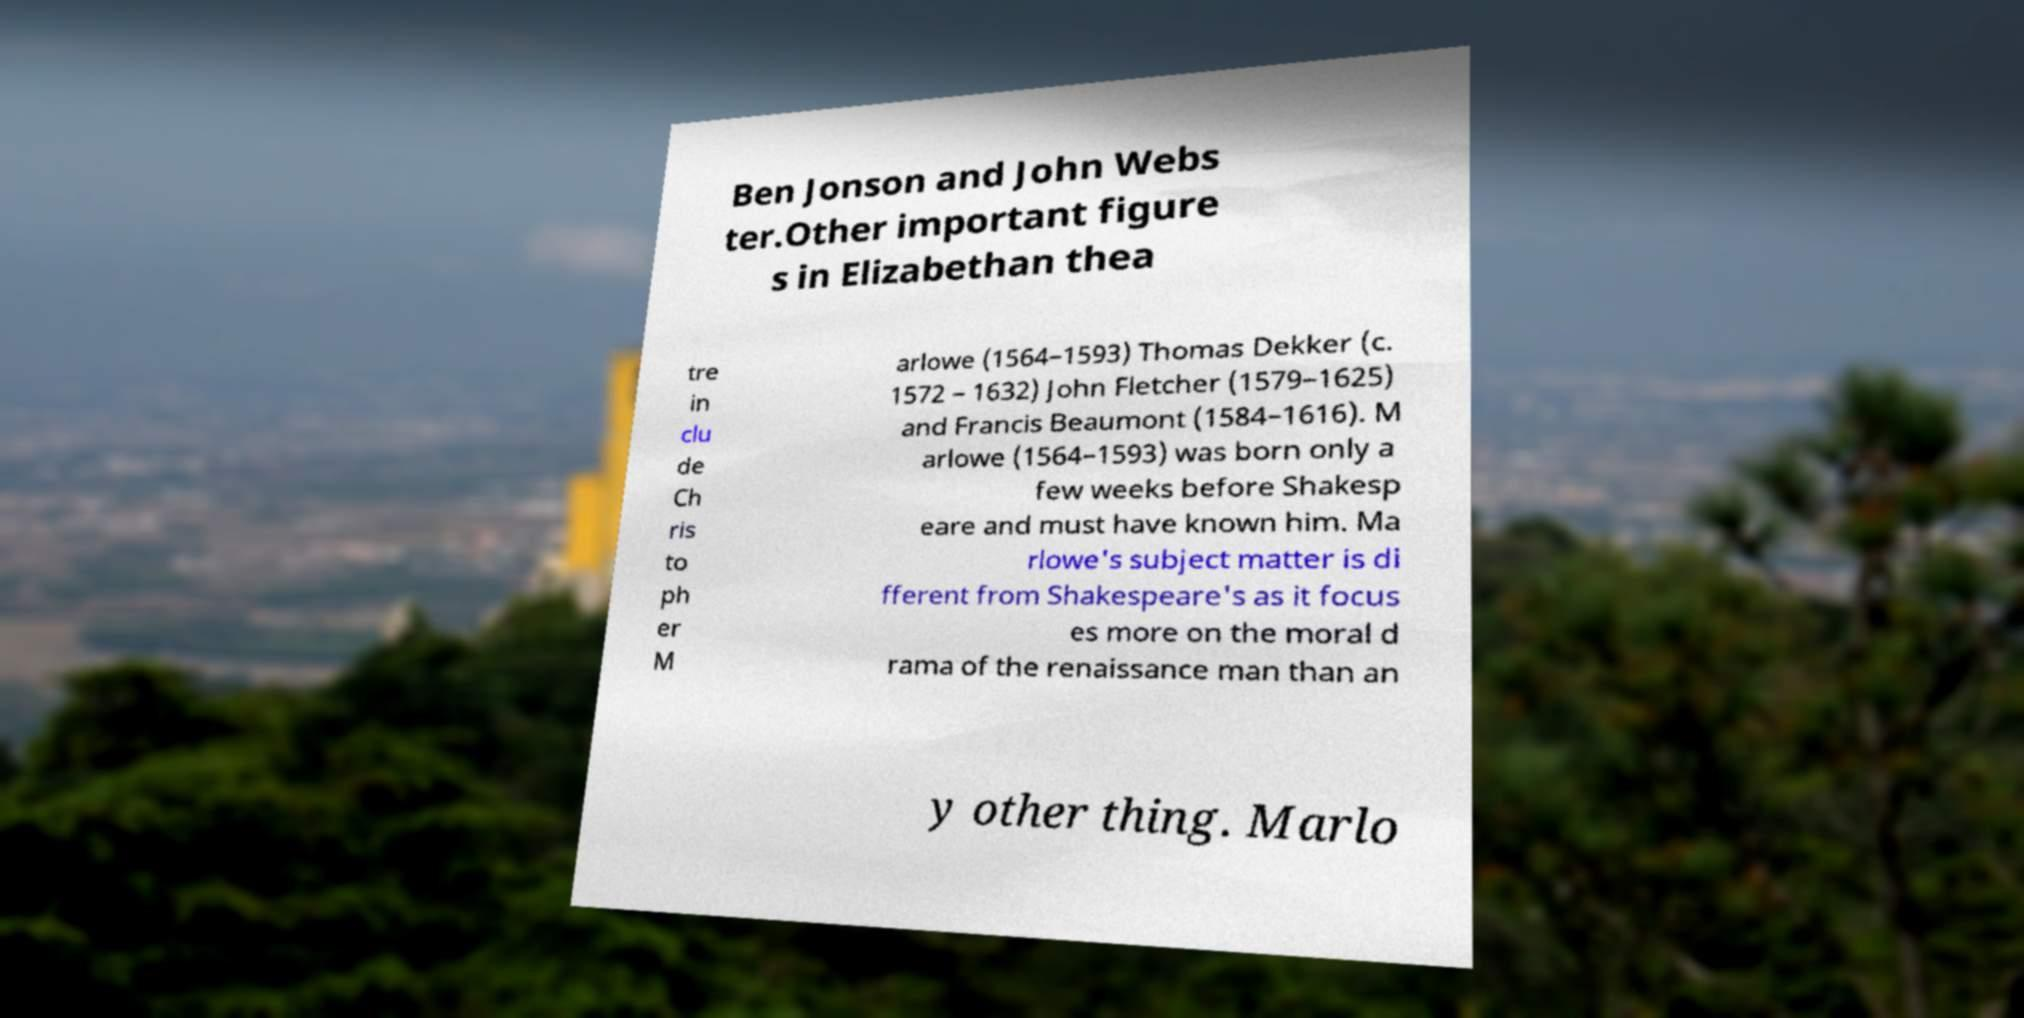Please identify and transcribe the text found in this image. Ben Jonson and John Webs ter.Other important figure s in Elizabethan thea tre in clu de Ch ris to ph er M arlowe (1564–1593) Thomas Dekker (c. 1572 – 1632) John Fletcher (1579–1625) and Francis Beaumont (1584–1616). M arlowe (1564–1593) was born only a few weeks before Shakesp eare and must have known him. Ma rlowe's subject matter is di fferent from Shakespeare's as it focus es more on the moral d rama of the renaissance man than an y other thing. Marlo 